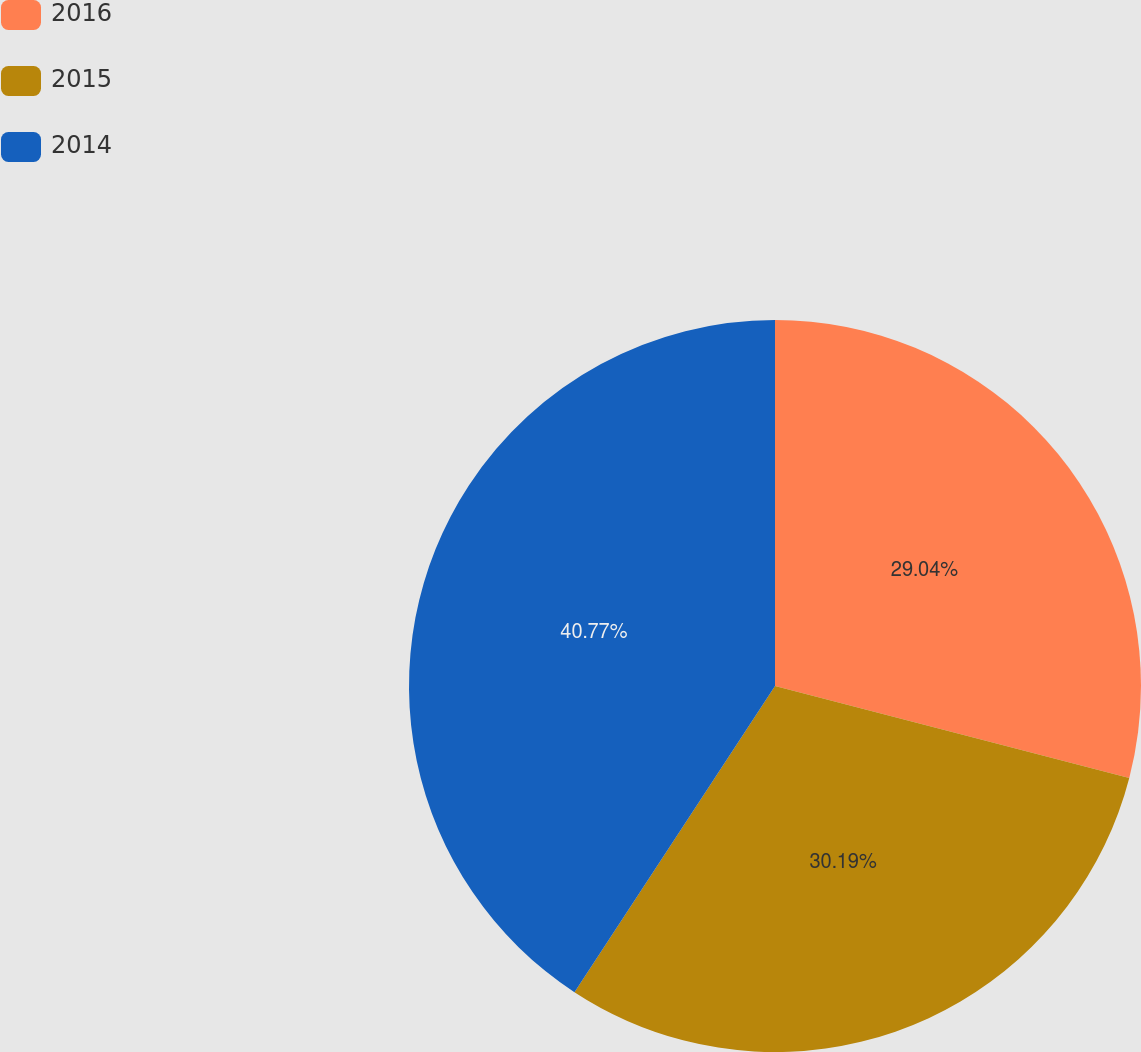<chart> <loc_0><loc_0><loc_500><loc_500><pie_chart><fcel>2016<fcel>2015<fcel>2014<nl><fcel>29.04%<fcel>30.19%<fcel>40.77%<nl></chart> 